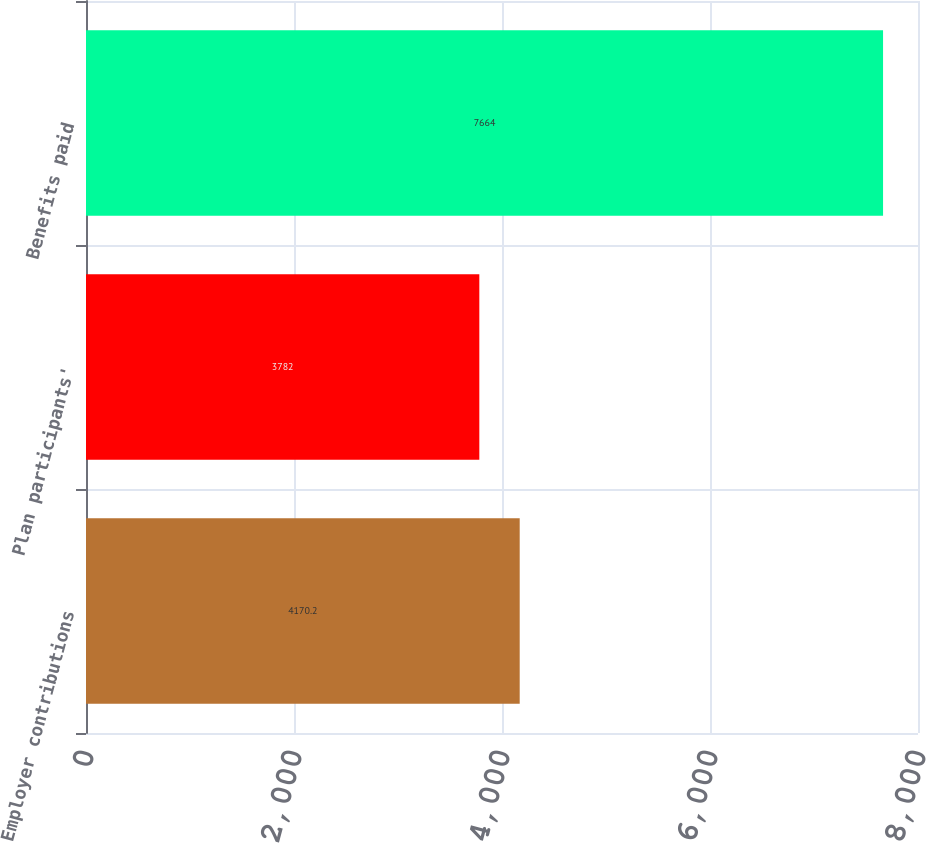<chart> <loc_0><loc_0><loc_500><loc_500><bar_chart><fcel>Employer contributions<fcel>Plan participants'<fcel>Benefits paid<nl><fcel>4170.2<fcel>3782<fcel>7664<nl></chart> 